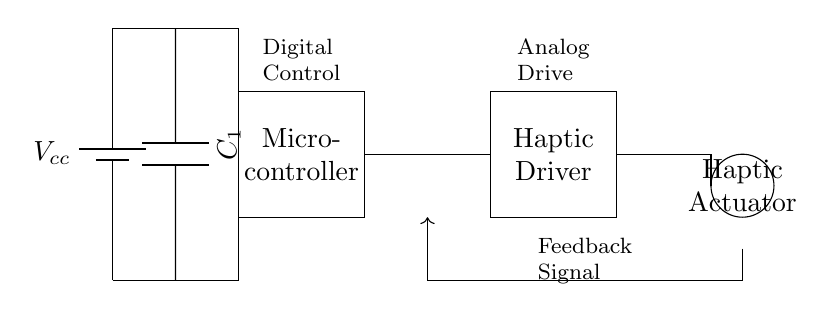What is the primary purpose of the microcontroller in this circuit? The microcontroller acts as the digital control unit that processes input signals and generates outputs to control the haptic driver.
Answer: Digital control What component is used for power smoothing? The circuit includes a capacitor labeled C1, which is used to smooth the power supply voltage to the system.
Answer: Capacitor What type of signal does the haptic driver utilize from the microcontroller? The haptic driver receives an analog drive signal generated by the microcontroller to control the haptic actuator's vibrations.
Answer: Analog drive How many components are connected to the power supply? Counting the battery, microcontroller, haptic driver, and capacitor, there are four components connected to the power supply.
Answer: Four What is the connection type between the haptic driver and the haptic actuator? The connection between the haptic driver and the haptic actuator is a direct connection, allowing the driver to send signals directly to the actuator.
Answer: Direct connection In which direction does the feedback signal flow in this circuit? The feedback signal flows from the haptic actuator back to the feedback path leading to the microcontroller for response adjustments.
Answer: Upward 